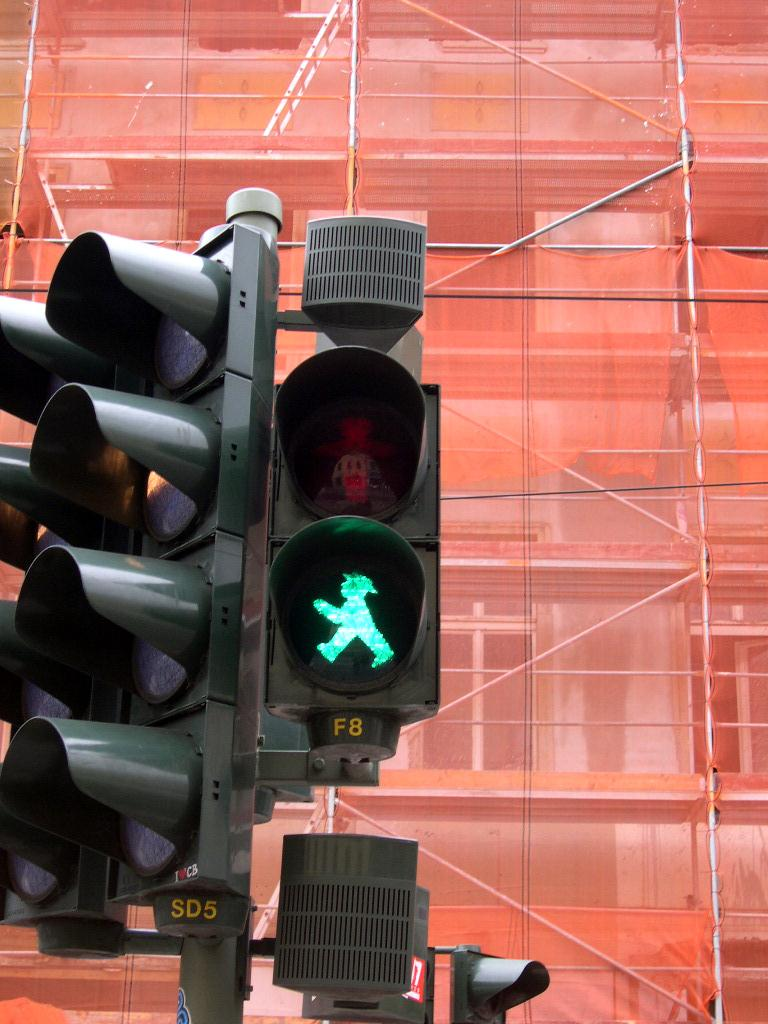<image>
Write a terse but informative summary of the picture. A pedestrian traffic light has F8 painted below it. 